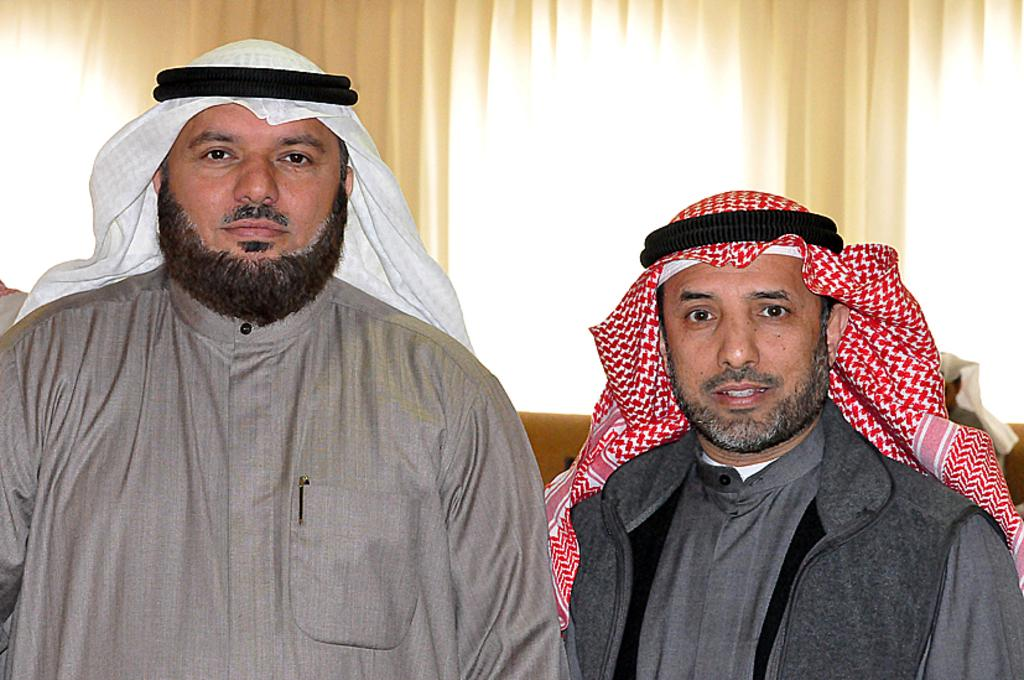Who is present in the image? There are people in the image. What are the people wearing on their heads? The people are wearing turbans. What can be seen in the background of the image? There are blinds in the background of the image. What type of music can be heard playing in the background of the image? There is no music present in the image, as it only shows people wearing turbans and blinds in the background. 